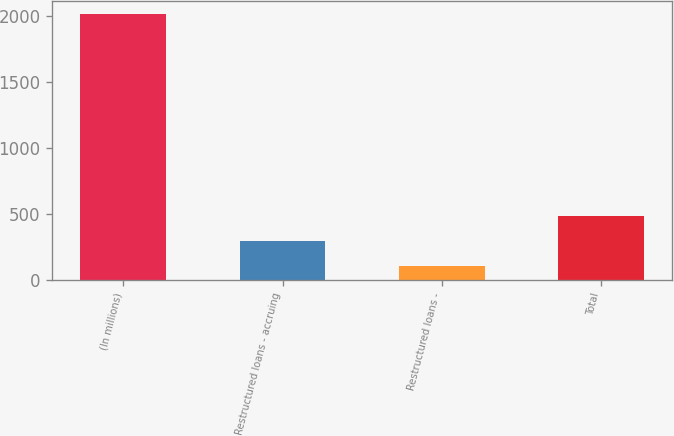Convert chart to OTSL. <chart><loc_0><loc_0><loc_500><loc_500><bar_chart><fcel>(In millions)<fcel>Restructured loans - accruing<fcel>Restructured loans -<fcel>Total<nl><fcel>2015<fcel>294.2<fcel>103<fcel>485.4<nl></chart> 